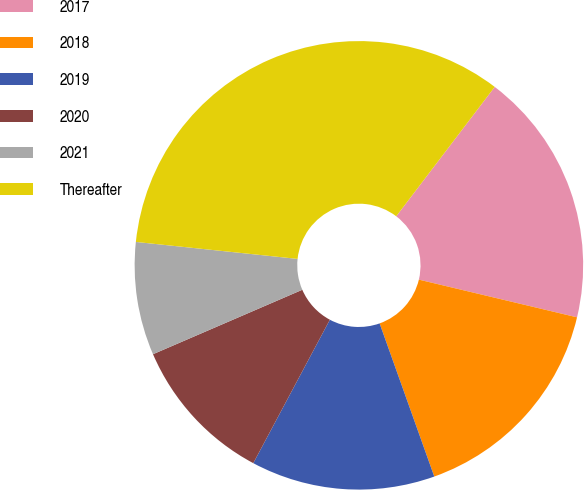<chart> <loc_0><loc_0><loc_500><loc_500><pie_chart><fcel>2017<fcel>2018<fcel>2019<fcel>2020<fcel>2021<fcel>Thereafter<nl><fcel>18.37%<fcel>15.82%<fcel>13.26%<fcel>10.71%<fcel>8.15%<fcel>33.69%<nl></chart> 